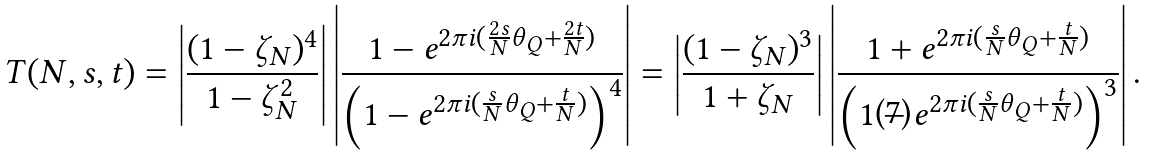<formula> <loc_0><loc_0><loc_500><loc_500>T ( N , s , t ) = \left | \frac { ( 1 - \zeta _ { N } ) ^ { 4 } } { 1 - \zeta _ { N } ^ { 2 } } \right | \left | \frac { 1 - e ^ { 2 \pi i ( \frac { 2 s } { N } \theta _ { Q } + \frac { 2 t } { N } ) } } { \left ( 1 - e ^ { 2 \pi i ( \frac { s } { N } \theta _ { Q } + \frac { t } { N } ) } \right ) ^ { 4 } } \right | = \left | \frac { ( 1 - \zeta _ { N } ) ^ { 3 } } { 1 + \zeta _ { N } } \right | \left | \frac { 1 + e ^ { 2 \pi i ( \frac { s } { N } \theta _ { Q } + \frac { t } { N } ) } } { \left ( 1 - e ^ { 2 \pi i ( \frac { s } { N } \theta _ { Q } + \frac { t } { N } ) } \right ) ^ { 3 } } \right | .</formula> 